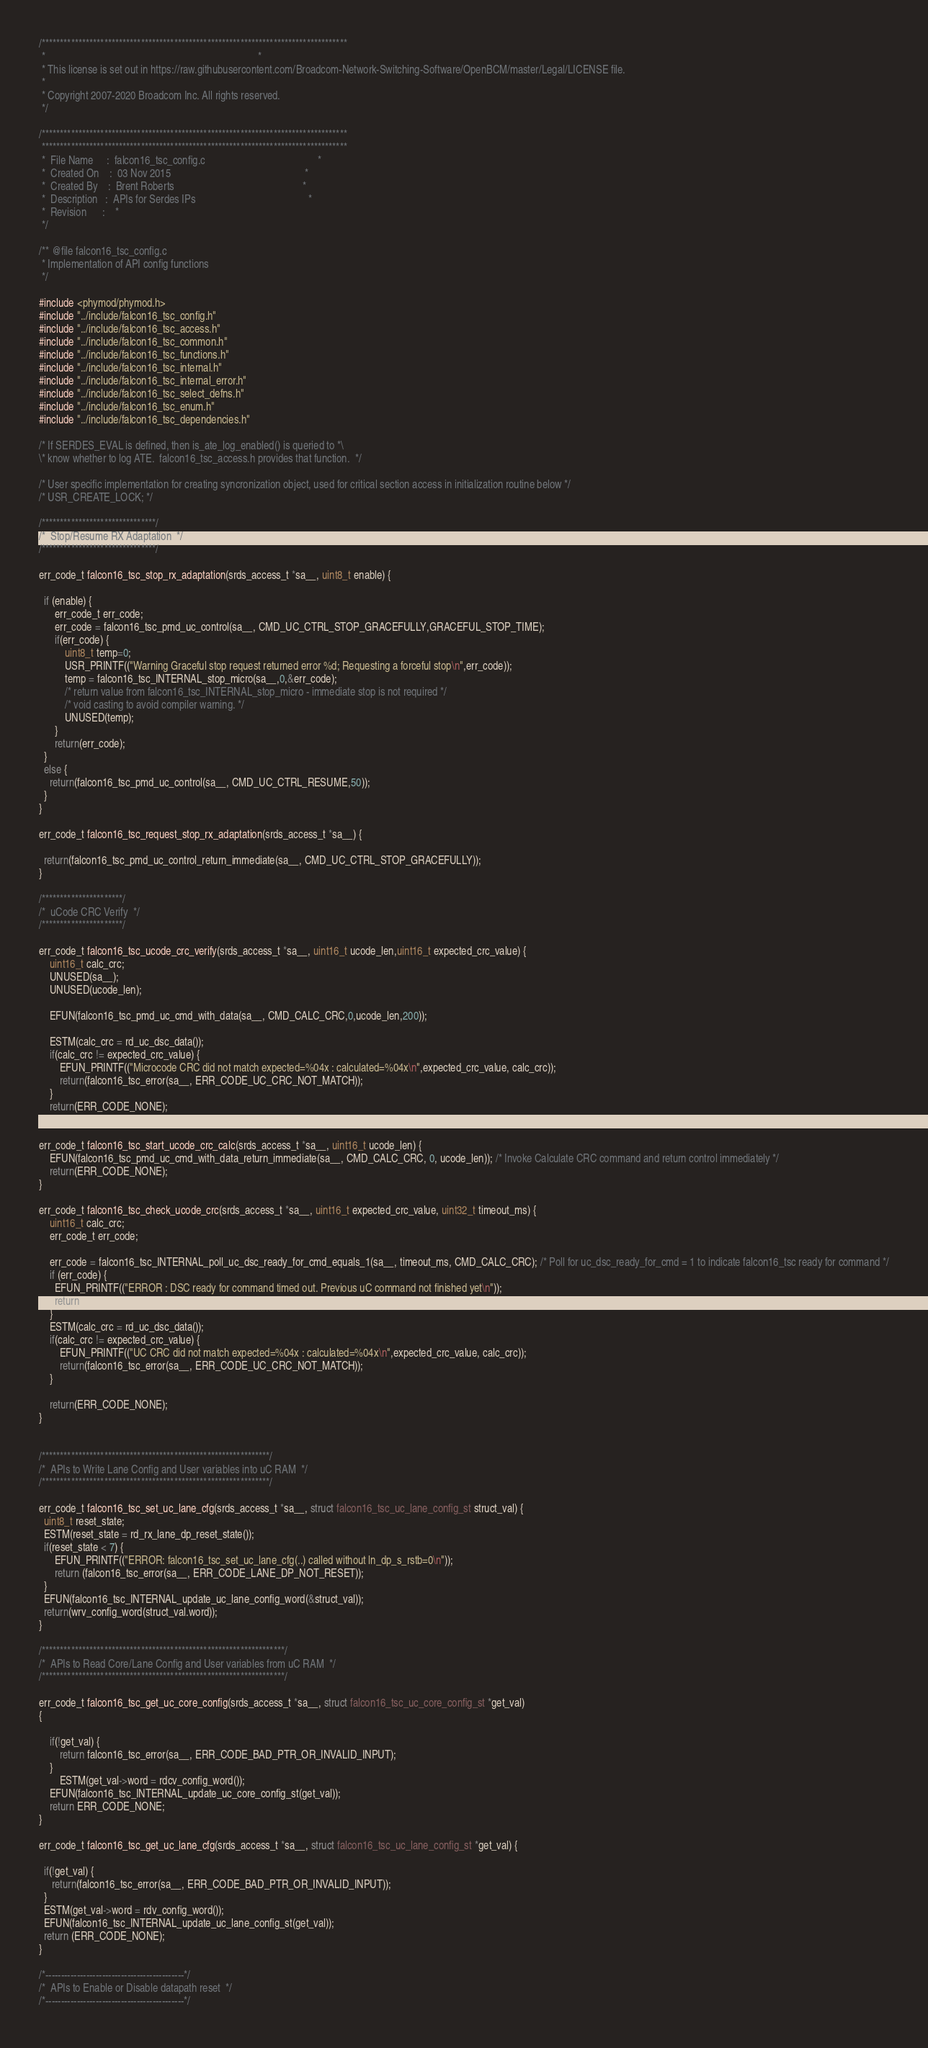<code> <loc_0><loc_0><loc_500><loc_500><_C_>/***********************************************************************************
 *                                                                                 *
 * This license is set out in https://raw.githubusercontent.com/Broadcom-Network-Switching-Software/OpenBCM/master/Legal/LICENSE file.
 * 
 * Copyright 2007-2020 Broadcom Inc. All rights reserved.
 */

/***********************************************************************************
 ***********************************************************************************
 *  File Name     :  falcon16_tsc_config.c                                           *
 *  Created On    :  03 Nov 2015                                                   *
 *  Created By    :  Brent Roberts                                                 *
 *  Description   :  APIs for Serdes IPs                                           *
 *  Revision      :    *
 */

/** @file falcon16_tsc_config.c
 * Implementation of API config functions
 */

#include <phymod/phymod.h>
#include "../include/falcon16_tsc_config.h"
#include "../include/falcon16_tsc_access.h"
#include "../include/falcon16_tsc_common.h"
#include "../include/falcon16_tsc_functions.h"
#include "../include/falcon16_tsc_internal.h"
#include "../include/falcon16_tsc_internal_error.h"
#include "../include/falcon16_tsc_select_defns.h"
#include "../include/falcon16_tsc_enum.h"
#include "../include/falcon16_tsc_dependencies.h"

/* If SERDES_EVAL is defined, then is_ate_log_enabled() is queried to *\
\* know whether to log ATE.  falcon16_tsc_access.h provides that function.  */

/* User specific implementation for creating syncronization object, used for critical section access in initialization routine below */
/* USR_CREATE_LOCK; */

/*******************************/
/*  Stop/Resume RX Adaptation  */
/*******************************/

err_code_t falcon16_tsc_stop_rx_adaptation(srds_access_t *sa__, uint8_t enable) {

  if (enable) {
      err_code_t err_code;
      err_code = falcon16_tsc_pmd_uc_control(sa__, CMD_UC_CTRL_STOP_GRACEFULLY,GRACEFUL_STOP_TIME);
      if(err_code) {
          uint8_t temp=0;
          USR_PRINTF(("Warning Graceful stop request returned error %d; Requesting a forceful stop\n",err_code));
          temp = falcon16_tsc_INTERNAL_stop_micro(sa__,0,&err_code);
          /* return value from falcon16_tsc_INTERNAL_stop_micro - immediate stop is not required */
          /* void casting to avoid compiler warning. */
          UNUSED(temp);
      }
      return(err_code);
  }
  else {
    return(falcon16_tsc_pmd_uc_control(sa__, CMD_UC_CTRL_RESUME,50));
  }
}

err_code_t falcon16_tsc_request_stop_rx_adaptation(srds_access_t *sa__) {

  return(falcon16_tsc_pmd_uc_control_return_immediate(sa__, CMD_UC_CTRL_STOP_GRACEFULLY));
}

/**********************/
/*  uCode CRC Verify  */
/**********************/

err_code_t falcon16_tsc_ucode_crc_verify(srds_access_t *sa__, uint16_t ucode_len,uint16_t expected_crc_value) {
    uint16_t calc_crc;
    UNUSED(sa__);
    UNUSED(ucode_len);

    EFUN(falcon16_tsc_pmd_uc_cmd_with_data(sa__, CMD_CALC_CRC,0,ucode_len,200));

    ESTM(calc_crc = rd_uc_dsc_data());
    if(calc_crc != expected_crc_value) {
        EFUN_PRINTF(("Microcode CRC did not match expected=%04x : calculated=%04x\n",expected_crc_value, calc_crc));
        return(falcon16_tsc_error(sa__, ERR_CODE_UC_CRC_NOT_MATCH));
    }
    return(ERR_CODE_NONE);
}

err_code_t falcon16_tsc_start_ucode_crc_calc(srds_access_t *sa__, uint16_t ucode_len) {
    EFUN(falcon16_tsc_pmd_uc_cmd_with_data_return_immediate(sa__, CMD_CALC_CRC, 0, ucode_len)); /* Invoke Calculate CRC command and return control immediately */
    return(ERR_CODE_NONE);
}

err_code_t falcon16_tsc_check_ucode_crc(srds_access_t *sa__, uint16_t expected_crc_value, uint32_t timeout_ms) {
    uint16_t calc_crc;
    err_code_t err_code;

    err_code = falcon16_tsc_INTERNAL_poll_uc_dsc_ready_for_cmd_equals_1(sa__, timeout_ms, CMD_CALC_CRC); /* Poll for uc_dsc_ready_for_cmd = 1 to indicate falcon16_tsc ready for command */
    if (err_code) {
      EFUN_PRINTF(("ERROR : DSC ready for command timed out. Previous uC command not finished yet\n"));
      return (err_code);
    }
    ESTM(calc_crc = rd_uc_dsc_data());
    if(calc_crc != expected_crc_value) {
        EFUN_PRINTF(("UC CRC did not match expected=%04x : calculated=%04x\n",expected_crc_value, calc_crc));
        return(falcon16_tsc_error(sa__, ERR_CODE_UC_CRC_NOT_MATCH));
    }

    return(ERR_CODE_NONE);
}


/**************************************************************/
/*  APIs to Write Lane Config and User variables into uC RAM  */
/**************************************************************/

err_code_t falcon16_tsc_set_uc_lane_cfg(srds_access_t *sa__, struct falcon16_tsc_uc_lane_config_st struct_val) {
  uint8_t reset_state;
  ESTM(reset_state = rd_rx_lane_dp_reset_state());
  if(reset_state < 7) {
      EFUN_PRINTF(("ERROR: falcon16_tsc_set_uc_lane_cfg(..) called without ln_dp_s_rstb=0\n"));
      return (falcon16_tsc_error(sa__, ERR_CODE_LANE_DP_NOT_RESET));
  }
  EFUN(falcon16_tsc_INTERNAL_update_uc_lane_config_word(&struct_val));
  return(wrv_config_word(struct_val.word));
}

/******************************************************************/
/*  APIs to Read Core/Lane Config and User variables from uC RAM  */
/******************************************************************/

err_code_t falcon16_tsc_get_uc_core_config(srds_access_t *sa__, struct falcon16_tsc_uc_core_config_st *get_val)
{
    
    if(!get_val) {
        return falcon16_tsc_error(sa__, ERR_CODE_BAD_PTR_OR_INVALID_INPUT);
    }
        ESTM(get_val->word = rdcv_config_word());
    EFUN(falcon16_tsc_INTERNAL_update_uc_core_config_st(get_val));
    return ERR_CODE_NONE;
}

err_code_t falcon16_tsc_get_uc_lane_cfg(srds_access_t *sa__, struct falcon16_tsc_uc_lane_config_st *get_val) {

  if(!get_val) {
     return(falcon16_tsc_error(sa__, ERR_CODE_BAD_PTR_OR_INVALID_INPUT));
  }
  ESTM(get_val->word = rdv_config_word());
  EFUN(falcon16_tsc_INTERNAL_update_uc_lane_config_st(get_val));
  return (ERR_CODE_NONE);
}

/*--------------------------------------------*/
/*  APIs to Enable or Disable datapath reset  */
/*--------------------------------------------*/
</code> 